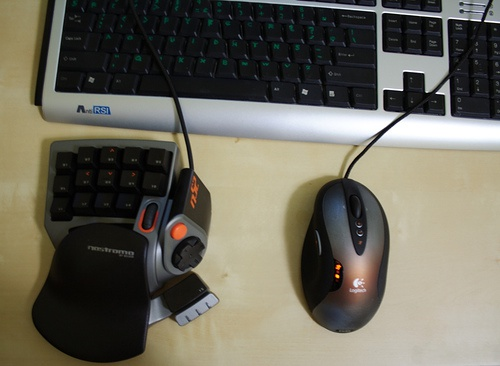Describe the objects in this image and their specific colors. I can see keyboard in olive, black, darkgray, lightgray, and gray tones and mouse in olive, black, gray, and maroon tones in this image. 